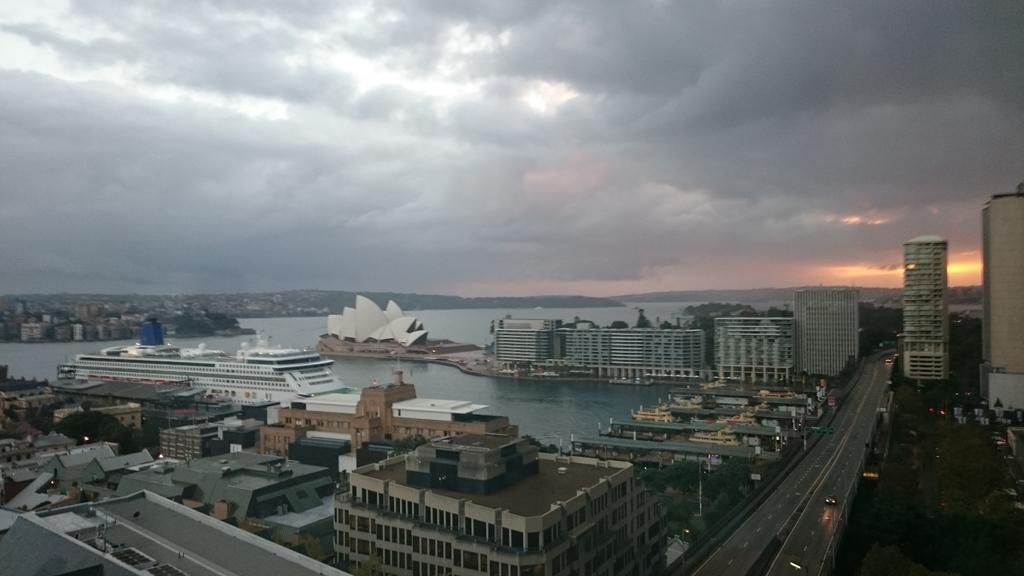What type of structures can be seen in the image? There are buildings in the image. What natural feature is present in the image? There is a water body (watership) in the image. What man-made features can be seen in the image? There are roads and vehicles in the image. What type of vegetation is present in the image? There are trees in the image. What type of infrastructure is present in the image? There are poles in the image. What is visible in the background of the image? The sky is visible in the background of the image, with clouds present. What type of grass is growing on the roof of the buildings in the image? There is no grass visible on the roofs of the buildings in the image. What type of government is depicted in the image? The image does not depict any government or political entity. 